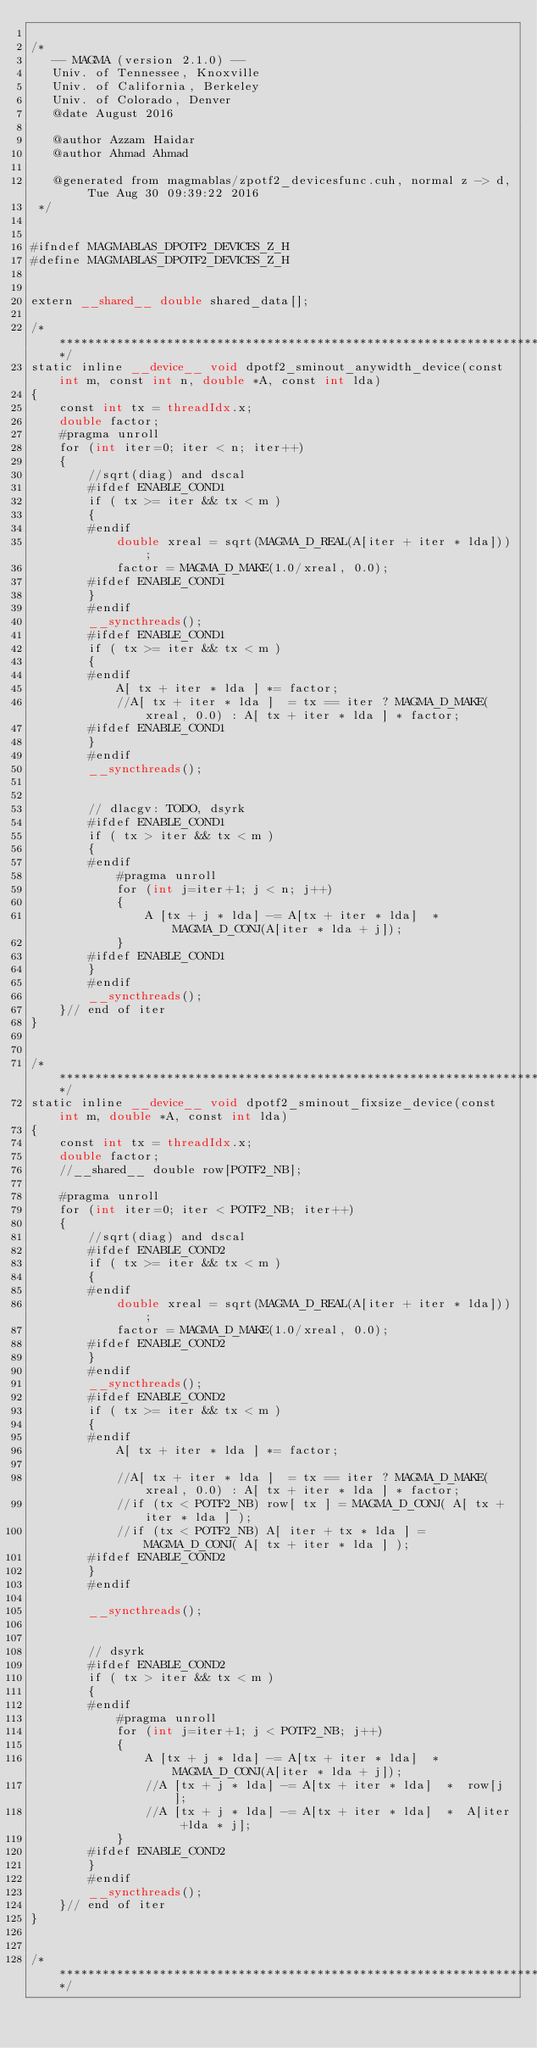<code> <loc_0><loc_0><loc_500><loc_500><_Cuda_>
/*
   -- MAGMA (version 2.1.0) --
   Univ. of Tennessee, Knoxville
   Univ. of California, Berkeley
   Univ. of Colorado, Denver
   @date August 2016

   @author Azzam Haidar
   @author Ahmad Ahmad

   @generated from magmablas/zpotf2_devicesfunc.cuh, normal z -> d, Tue Aug 30 09:39:22 2016
 */


#ifndef MAGMABLAS_DPOTF2_DEVICES_Z_H
#define MAGMABLAS_DPOTF2_DEVICES_Z_H


extern __shared__ double shared_data[];

/******************************************************************************/
static inline __device__ void dpotf2_sminout_anywidth_device(const int m, const int n, double *A, const int lda)
{
    const int tx = threadIdx.x;
    double factor;
    #pragma unroll
    for (int iter=0; iter < n; iter++)
    {
        //sqrt(diag) and dscal
        #ifdef ENABLE_COND1
        if ( tx >= iter && tx < m )
        {
        #endif
            double xreal = sqrt(MAGMA_D_REAL(A[iter + iter * lda]));
            factor = MAGMA_D_MAKE(1.0/xreal, 0.0);
        #ifdef ENABLE_COND1
        }
        #endif
        __syncthreads();
        #ifdef ENABLE_COND1
        if ( tx >= iter && tx < m )
        {
        #endif
            A[ tx + iter * lda ] *= factor;
            //A[ tx + iter * lda ]  = tx == iter ? MAGMA_D_MAKE(xreal, 0.0) : A[ tx + iter * lda ] * factor;
        #ifdef ENABLE_COND1
        }
        #endif
        __syncthreads();


        // dlacgv: TODO, dsyrk
        #ifdef ENABLE_COND1
        if ( tx > iter && tx < m )
        {
        #endif
            #pragma unroll 
            for (int j=iter+1; j < n; j++)
            {
                A [tx + j * lda] -= A[tx + iter * lda]  *  MAGMA_D_CONJ(A[iter * lda + j]);
            }   
        #ifdef ENABLE_COND1
        }
        #endif
        __syncthreads();
    }// end of iter
}


/******************************************************************************/
static inline __device__ void dpotf2_sminout_fixsize_device(const int m, double *A, const int lda)
{
    const int tx = threadIdx.x;
    double factor;
    //__shared__ double row[POTF2_NB];

    #pragma unroll
    for (int iter=0; iter < POTF2_NB; iter++)
    {
        //sqrt(diag) and dscal
        #ifdef ENABLE_COND2
        if ( tx >= iter && tx < m )
        {
        #endif
            double xreal = sqrt(MAGMA_D_REAL(A[iter + iter * lda]));
            factor = MAGMA_D_MAKE(1.0/xreal, 0.0);
        #ifdef ENABLE_COND2
        }
        #endif
        __syncthreads();
        #ifdef ENABLE_COND2
        if ( tx >= iter && tx < m )
        {
        #endif
            A[ tx + iter * lda ] *= factor;

            //A[ tx + iter * lda ]  = tx == iter ? MAGMA_D_MAKE(xreal, 0.0) : A[ tx + iter * lda ] * factor;
            //if (tx < POTF2_NB) row[ tx ] = MAGMA_D_CONJ( A[ tx + iter * lda ] );
            //if (tx < POTF2_NB) A[ iter + tx * lda ] = MAGMA_D_CONJ( A[ tx + iter * lda ] );
        #ifdef ENABLE_COND2
        }
        #endif

        __syncthreads();


        // dsyrk
        #ifdef ENABLE_COND2
        if ( tx > iter && tx < m )
        {
        #endif
            #pragma unroll
            for (int j=iter+1; j < POTF2_NB; j++)
            {
                A [tx + j * lda] -= A[tx + iter * lda]  *  MAGMA_D_CONJ(A[iter * lda + j]);
                //A [tx + j * lda] -= A[tx + iter * lda]  *  row[j];
                //A [tx + j * lda] -= A[tx + iter * lda]  *  A[iter +lda * j];
            }   
        #ifdef ENABLE_COND2
        }
        #endif
        __syncthreads();
    }// end of iter
}


/******************************************************************************/</code> 